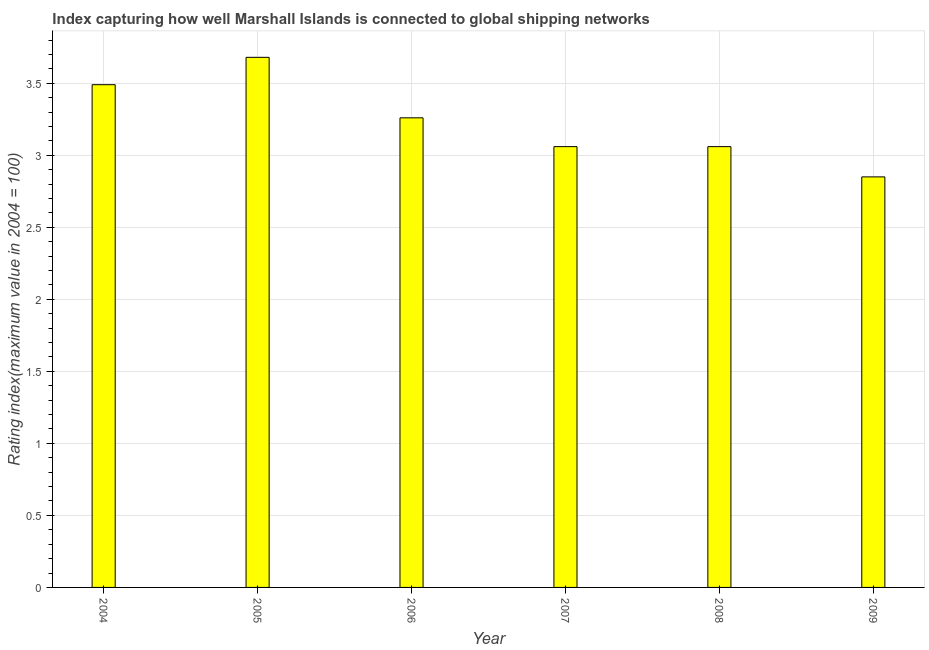Does the graph contain grids?
Ensure brevity in your answer.  Yes. What is the title of the graph?
Your answer should be very brief. Index capturing how well Marshall Islands is connected to global shipping networks. What is the label or title of the X-axis?
Make the answer very short. Year. What is the label or title of the Y-axis?
Your answer should be very brief. Rating index(maximum value in 2004 = 100). What is the liner shipping connectivity index in 2009?
Offer a very short reply. 2.85. Across all years, what is the maximum liner shipping connectivity index?
Your response must be concise. 3.68. Across all years, what is the minimum liner shipping connectivity index?
Offer a very short reply. 2.85. What is the sum of the liner shipping connectivity index?
Your response must be concise. 19.4. What is the difference between the liner shipping connectivity index in 2005 and 2009?
Make the answer very short. 0.83. What is the average liner shipping connectivity index per year?
Offer a terse response. 3.23. What is the median liner shipping connectivity index?
Your answer should be compact. 3.16. What is the ratio of the liner shipping connectivity index in 2005 to that in 2007?
Make the answer very short. 1.2. Is the liner shipping connectivity index in 2005 less than that in 2006?
Give a very brief answer. No. What is the difference between the highest and the second highest liner shipping connectivity index?
Your answer should be compact. 0.19. What is the difference between the highest and the lowest liner shipping connectivity index?
Ensure brevity in your answer.  0.83. How many bars are there?
Provide a short and direct response. 6. What is the difference between two consecutive major ticks on the Y-axis?
Provide a short and direct response. 0.5. What is the Rating index(maximum value in 2004 = 100) in 2004?
Your answer should be very brief. 3.49. What is the Rating index(maximum value in 2004 = 100) of 2005?
Provide a short and direct response. 3.68. What is the Rating index(maximum value in 2004 = 100) in 2006?
Keep it short and to the point. 3.26. What is the Rating index(maximum value in 2004 = 100) of 2007?
Your response must be concise. 3.06. What is the Rating index(maximum value in 2004 = 100) of 2008?
Give a very brief answer. 3.06. What is the Rating index(maximum value in 2004 = 100) in 2009?
Your answer should be very brief. 2.85. What is the difference between the Rating index(maximum value in 2004 = 100) in 2004 and 2005?
Make the answer very short. -0.19. What is the difference between the Rating index(maximum value in 2004 = 100) in 2004 and 2006?
Ensure brevity in your answer.  0.23. What is the difference between the Rating index(maximum value in 2004 = 100) in 2004 and 2007?
Ensure brevity in your answer.  0.43. What is the difference between the Rating index(maximum value in 2004 = 100) in 2004 and 2008?
Ensure brevity in your answer.  0.43. What is the difference between the Rating index(maximum value in 2004 = 100) in 2004 and 2009?
Make the answer very short. 0.64. What is the difference between the Rating index(maximum value in 2004 = 100) in 2005 and 2006?
Your answer should be compact. 0.42. What is the difference between the Rating index(maximum value in 2004 = 100) in 2005 and 2007?
Offer a very short reply. 0.62. What is the difference between the Rating index(maximum value in 2004 = 100) in 2005 and 2008?
Provide a succinct answer. 0.62. What is the difference between the Rating index(maximum value in 2004 = 100) in 2005 and 2009?
Your response must be concise. 0.83. What is the difference between the Rating index(maximum value in 2004 = 100) in 2006 and 2008?
Ensure brevity in your answer.  0.2. What is the difference between the Rating index(maximum value in 2004 = 100) in 2006 and 2009?
Your answer should be very brief. 0.41. What is the difference between the Rating index(maximum value in 2004 = 100) in 2007 and 2009?
Ensure brevity in your answer.  0.21. What is the difference between the Rating index(maximum value in 2004 = 100) in 2008 and 2009?
Provide a succinct answer. 0.21. What is the ratio of the Rating index(maximum value in 2004 = 100) in 2004 to that in 2005?
Offer a terse response. 0.95. What is the ratio of the Rating index(maximum value in 2004 = 100) in 2004 to that in 2006?
Your answer should be very brief. 1.07. What is the ratio of the Rating index(maximum value in 2004 = 100) in 2004 to that in 2007?
Offer a very short reply. 1.14. What is the ratio of the Rating index(maximum value in 2004 = 100) in 2004 to that in 2008?
Provide a succinct answer. 1.14. What is the ratio of the Rating index(maximum value in 2004 = 100) in 2004 to that in 2009?
Keep it short and to the point. 1.23. What is the ratio of the Rating index(maximum value in 2004 = 100) in 2005 to that in 2006?
Your answer should be very brief. 1.13. What is the ratio of the Rating index(maximum value in 2004 = 100) in 2005 to that in 2007?
Your response must be concise. 1.2. What is the ratio of the Rating index(maximum value in 2004 = 100) in 2005 to that in 2008?
Keep it short and to the point. 1.2. What is the ratio of the Rating index(maximum value in 2004 = 100) in 2005 to that in 2009?
Ensure brevity in your answer.  1.29. What is the ratio of the Rating index(maximum value in 2004 = 100) in 2006 to that in 2007?
Provide a succinct answer. 1.06. What is the ratio of the Rating index(maximum value in 2004 = 100) in 2006 to that in 2008?
Your answer should be compact. 1.06. What is the ratio of the Rating index(maximum value in 2004 = 100) in 2006 to that in 2009?
Ensure brevity in your answer.  1.14. What is the ratio of the Rating index(maximum value in 2004 = 100) in 2007 to that in 2009?
Offer a terse response. 1.07. What is the ratio of the Rating index(maximum value in 2004 = 100) in 2008 to that in 2009?
Your answer should be compact. 1.07. 